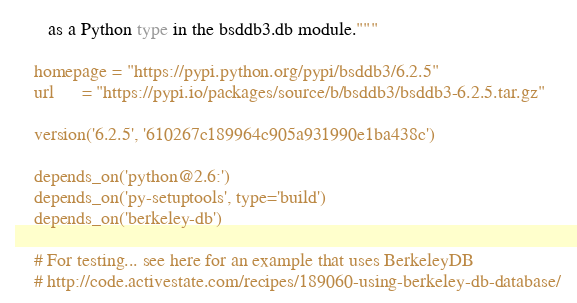Convert code to text. <code><loc_0><loc_0><loc_500><loc_500><_Python_>       as a Python type in the bsddb3.db module."""

    homepage = "https://pypi.python.org/pypi/bsddb3/6.2.5"
    url      = "https://pypi.io/packages/source/b/bsddb3/bsddb3-6.2.5.tar.gz"

    version('6.2.5', '610267c189964c905a931990e1ba438c')

    depends_on('python@2.6:')
    depends_on('py-setuptools', type='build')
    depends_on('berkeley-db')

    # For testing... see here for an example that uses BerkeleyDB
    # http://code.activestate.com/recipes/189060-using-berkeley-db-database/
</code> 